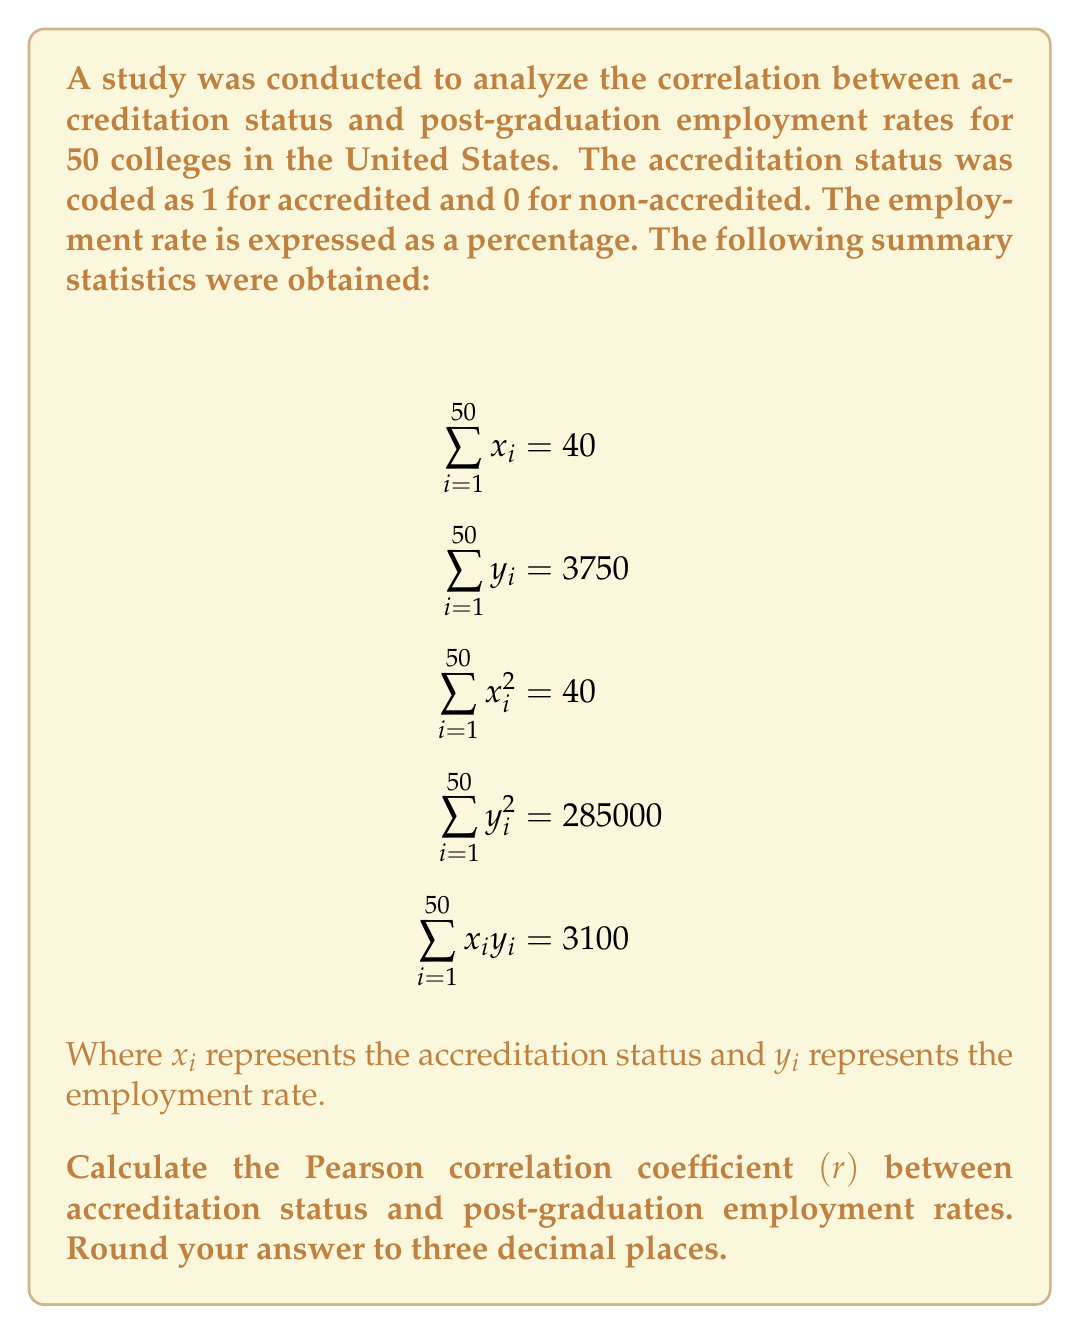What is the answer to this math problem? To calculate the Pearson correlation coefficient, we'll use the formula:

$$r = \frac{n\sum x_iy_i - \sum x_i \sum y_i}{\sqrt{[n\sum x_i^2 - (\sum x_i)^2][n\sum y_i^2 - (\sum y_i)^2]}}$$

Where $n$ is the number of colleges (50 in this case).

Step 1: Calculate $n\sum x_iy_i$
$n\sum x_iy_i = 50 \times 3100 = 155000$

Step 2: Calculate $\sum x_i \sum y_i$
$\sum x_i \sum y_i = 40 \times 3750 = 150000$

Step 3: Calculate the numerator
$155000 - 150000 = 5000$

Step 4: Calculate $n\sum x_i^2$ and $(\sum x_i)^2$
$n\sum x_i^2 = 50 \times 40 = 2000$
$(\sum x_i)^2 = 40^2 = 1600$

Step 5: Calculate $n\sum y_i^2$ and $(\sum y_i)^2$
$n\sum y_i^2 = 50 \times 285000 = 14250000$
$(\sum y_i)^2 = 3750^2 = 14062500$

Step 6: Calculate the denominator
$\sqrt{(2000 - 1600)(14250000 - 14062500)} = \sqrt{400 \times 187500} = \sqrt{75000000} = 8660.254$

Step 7: Calculate the correlation coefficient
$r = \frac{5000}{8660.254} = 0.577$

Step 8: Round to three decimal places
$r = 0.577$
Answer: 0.577 